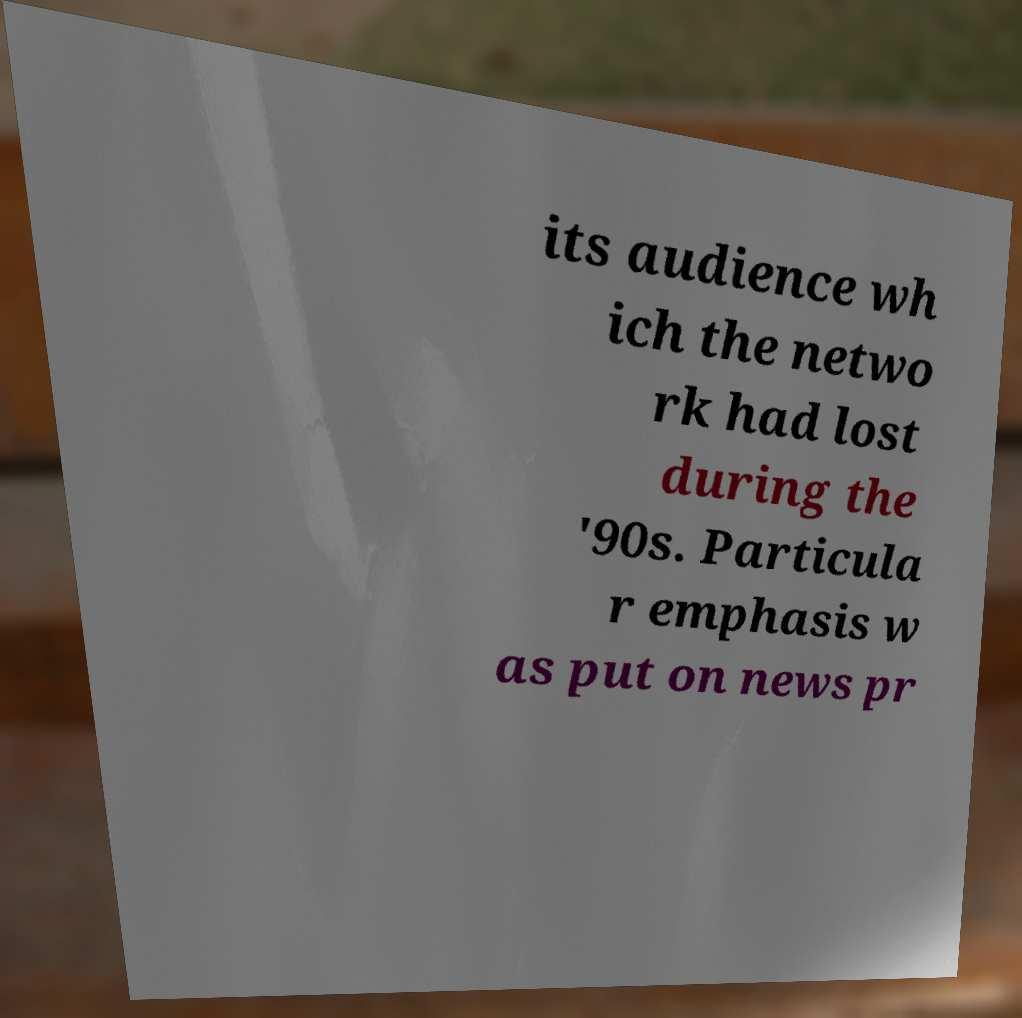Please identify and transcribe the text found in this image. its audience wh ich the netwo rk had lost during the '90s. Particula r emphasis w as put on news pr 